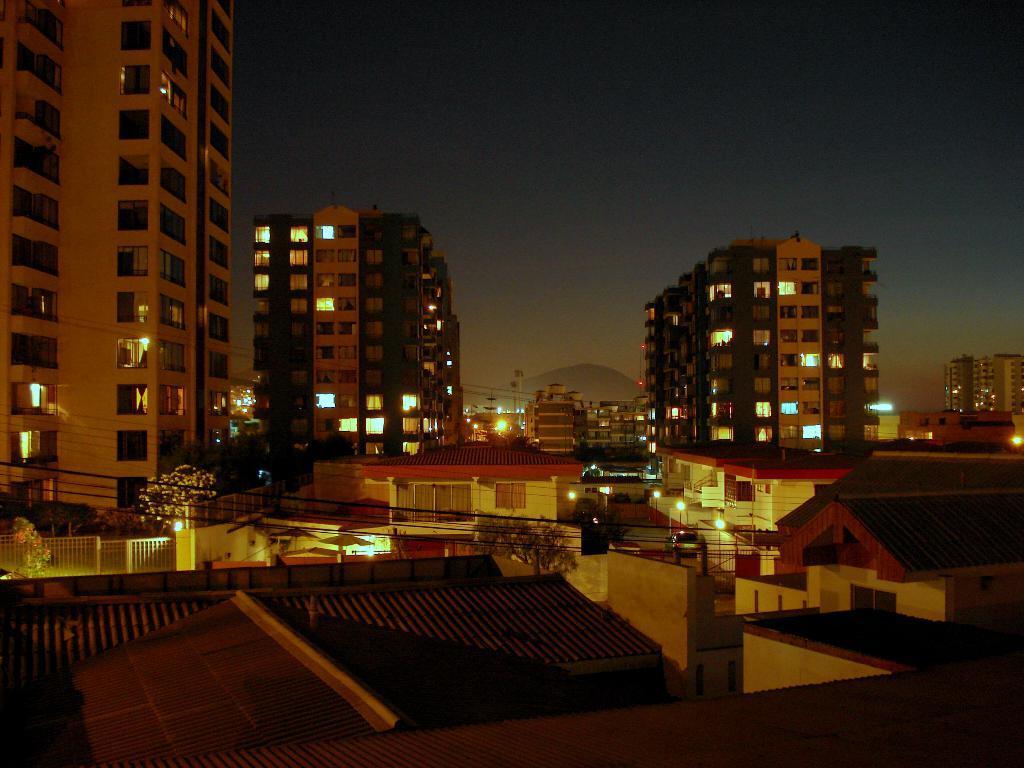In one or two sentences, can you explain what this image depicts? In this image we can see some buildings, trees, lights and in the background of the image there is mountain and clear sky. 